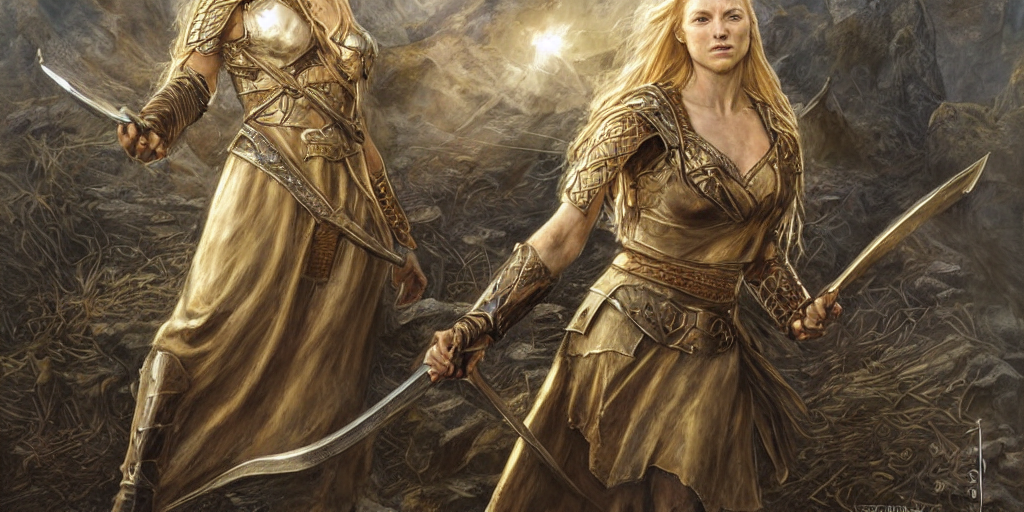Are there any quality issues with this image? The image appears to be of high quality with no obvious signs of compression artifacts or distortion. The resolution seems sufficient to discern fine details such as the texture of the clothing and the expressions on the characters' faces. 